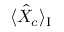<formula> <loc_0><loc_0><loc_500><loc_500>\langle \hat { X } _ { c } \rangle _ { I }</formula> 